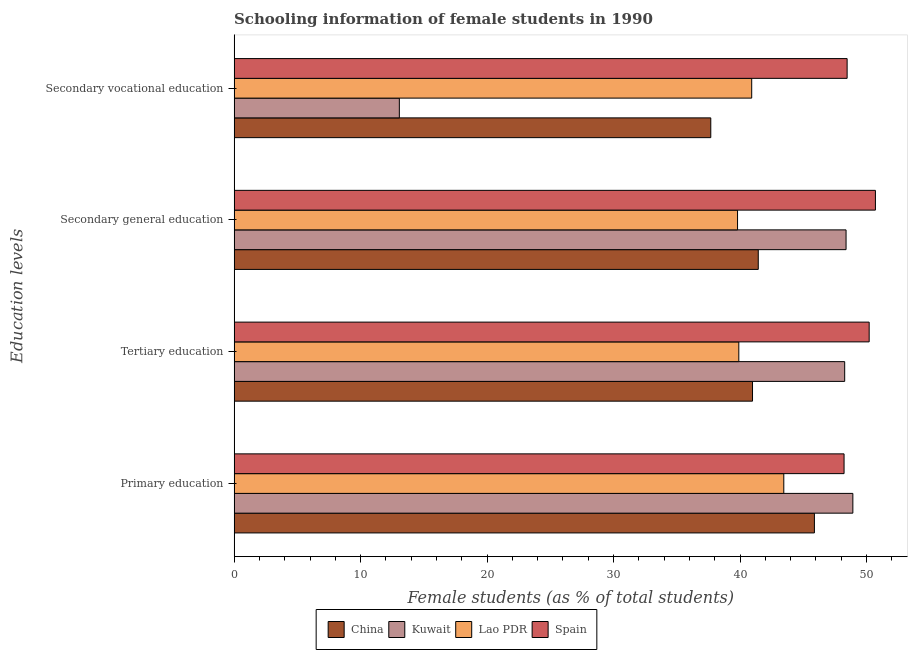How many different coloured bars are there?
Provide a succinct answer. 4. How many groups of bars are there?
Ensure brevity in your answer.  4. What is the label of the 1st group of bars from the top?
Provide a succinct answer. Secondary vocational education. What is the percentage of female students in secondary vocational education in Kuwait?
Make the answer very short. 13.06. Across all countries, what is the maximum percentage of female students in primary education?
Make the answer very short. 48.92. Across all countries, what is the minimum percentage of female students in secondary education?
Provide a short and direct response. 39.8. In which country was the percentage of female students in primary education minimum?
Make the answer very short. Lao PDR. What is the total percentage of female students in tertiary education in the graph?
Offer a very short reply. 179.38. What is the difference between the percentage of female students in primary education in China and that in Kuwait?
Provide a short and direct response. -3.04. What is the difference between the percentage of female students in secondary vocational education in China and the percentage of female students in tertiary education in Lao PDR?
Your answer should be very brief. -2.22. What is the average percentage of female students in secondary vocational education per country?
Offer a very short reply. 35.04. What is the difference between the percentage of female students in primary education and percentage of female students in secondary vocational education in Kuwait?
Provide a short and direct response. 35.86. In how many countries, is the percentage of female students in secondary education greater than 30 %?
Your answer should be very brief. 4. What is the ratio of the percentage of female students in secondary vocational education in Lao PDR to that in Spain?
Make the answer very short. 0.84. Is the percentage of female students in tertiary education in China less than that in Lao PDR?
Offer a terse response. No. What is the difference between the highest and the second highest percentage of female students in tertiary education?
Your response must be concise. 1.94. What is the difference between the highest and the lowest percentage of female students in primary education?
Offer a terse response. 5.46. Is it the case that in every country, the sum of the percentage of female students in secondary education and percentage of female students in tertiary education is greater than the sum of percentage of female students in secondary vocational education and percentage of female students in primary education?
Give a very brief answer. No. What does the 3rd bar from the top in Tertiary education represents?
Ensure brevity in your answer.  Kuwait. What does the 3rd bar from the bottom in Tertiary education represents?
Give a very brief answer. Lao PDR. Is it the case that in every country, the sum of the percentage of female students in primary education and percentage of female students in tertiary education is greater than the percentage of female students in secondary education?
Your response must be concise. Yes. How many bars are there?
Your response must be concise. 16. Are all the bars in the graph horizontal?
Your answer should be very brief. Yes. How many countries are there in the graph?
Make the answer very short. 4. Does the graph contain any zero values?
Give a very brief answer. No. How many legend labels are there?
Provide a short and direct response. 4. How are the legend labels stacked?
Make the answer very short. Horizontal. What is the title of the graph?
Ensure brevity in your answer.  Schooling information of female students in 1990. What is the label or title of the X-axis?
Give a very brief answer. Female students (as % of total students). What is the label or title of the Y-axis?
Ensure brevity in your answer.  Education levels. What is the Female students (as % of total students) of China in Primary education?
Give a very brief answer. 45.88. What is the Female students (as % of total students) of Kuwait in Primary education?
Provide a short and direct response. 48.92. What is the Female students (as % of total students) in Lao PDR in Primary education?
Provide a succinct answer. 43.46. What is the Female students (as % of total students) in Spain in Primary education?
Offer a terse response. 48.23. What is the Female students (as % of total students) in China in Tertiary education?
Your answer should be very brief. 40.99. What is the Female students (as % of total students) of Kuwait in Tertiary education?
Offer a terse response. 48.28. What is the Female students (as % of total students) in Lao PDR in Tertiary education?
Provide a succinct answer. 39.9. What is the Female students (as % of total students) in Spain in Tertiary education?
Your answer should be compact. 50.21. What is the Female students (as % of total students) in China in Secondary general education?
Offer a terse response. 41.44. What is the Female students (as % of total students) of Kuwait in Secondary general education?
Offer a very short reply. 48.38. What is the Female students (as % of total students) in Lao PDR in Secondary general education?
Give a very brief answer. 39.8. What is the Female students (as % of total students) in Spain in Secondary general education?
Provide a short and direct response. 50.71. What is the Female students (as % of total students) in China in Secondary vocational education?
Provide a succinct answer. 37.69. What is the Female students (as % of total students) of Kuwait in Secondary vocational education?
Make the answer very short. 13.06. What is the Female students (as % of total students) in Lao PDR in Secondary vocational education?
Give a very brief answer. 40.92. What is the Female students (as % of total students) in Spain in Secondary vocational education?
Your answer should be compact. 48.47. Across all Education levels, what is the maximum Female students (as % of total students) of China?
Ensure brevity in your answer.  45.88. Across all Education levels, what is the maximum Female students (as % of total students) in Kuwait?
Your answer should be very brief. 48.92. Across all Education levels, what is the maximum Female students (as % of total students) in Lao PDR?
Ensure brevity in your answer.  43.46. Across all Education levels, what is the maximum Female students (as % of total students) of Spain?
Provide a short and direct response. 50.71. Across all Education levels, what is the minimum Female students (as % of total students) in China?
Make the answer very short. 37.69. Across all Education levels, what is the minimum Female students (as % of total students) of Kuwait?
Make the answer very short. 13.06. Across all Education levels, what is the minimum Female students (as % of total students) in Lao PDR?
Make the answer very short. 39.8. Across all Education levels, what is the minimum Female students (as % of total students) in Spain?
Offer a very short reply. 48.23. What is the total Female students (as % of total students) of China in the graph?
Your answer should be compact. 166. What is the total Female students (as % of total students) in Kuwait in the graph?
Provide a short and direct response. 158.65. What is the total Female students (as % of total students) of Lao PDR in the graph?
Your answer should be very brief. 164.09. What is the total Female students (as % of total students) in Spain in the graph?
Offer a terse response. 197.61. What is the difference between the Female students (as % of total students) of China in Primary education and that in Tertiary education?
Offer a very short reply. 4.89. What is the difference between the Female students (as % of total students) in Kuwait in Primary education and that in Tertiary education?
Provide a short and direct response. 0.65. What is the difference between the Female students (as % of total students) in Lao PDR in Primary education and that in Tertiary education?
Your response must be concise. 3.56. What is the difference between the Female students (as % of total students) in Spain in Primary education and that in Tertiary education?
Offer a terse response. -1.98. What is the difference between the Female students (as % of total students) of China in Primary education and that in Secondary general education?
Your answer should be compact. 4.44. What is the difference between the Female students (as % of total students) in Kuwait in Primary education and that in Secondary general education?
Your response must be concise. 0.54. What is the difference between the Female students (as % of total students) in Lao PDR in Primary education and that in Secondary general education?
Offer a terse response. 3.66. What is the difference between the Female students (as % of total students) of Spain in Primary education and that in Secondary general education?
Offer a terse response. -2.48. What is the difference between the Female students (as % of total students) of China in Primary education and that in Secondary vocational education?
Provide a short and direct response. 8.19. What is the difference between the Female students (as % of total students) of Kuwait in Primary education and that in Secondary vocational education?
Ensure brevity in your answer.  35.86. What is the difference between the Female students (as % of total students) of Lao PDR in Primary education and that in Secondary vocational education?
Your response must be concise. 2.54. What is the difference between the Female students (as % of total students) in Spain in Primary education and that in Secondary vocational education?
Offer a terse response. -0.24. What is the difference between the Female students (as % of total students) in China in Tertiary education and that in Secondary general education?
Offer a terse response. -0.45. What is the difference between the Female students (as % of total students) of Kuwait in Tertiary education and that in Secondary general education?
Make the answer very short. -0.11. What is the difference between the Female students (as % of total students) in Lao PDR in Tertiary education and that in Secondary general education?
Ensure brevity in your answer.  0.1. What is the difference between the Female students (as % of total students) of Spain in Tertiary education and that in Secondary general education?
Give a very brief answer. -0.49. What is the difference between the Female students (as % of total students) in China in Tertiary education and that in Secondary vocational education?
Give a very brief answer. 3.3. What is the difference between the Female students (as % of total students) in Kuwait in Tertiary education and that in Secondary vocational education?
Offer a very short reply. 35.21. What is the difference between the Female students (as % of total students) of Lao PDR in Tertiary education and that in Secondary vocational education?
Your response must be concise. -1.02. What is the difference between the Female students (as % of total students) in Spain in Tertiary education and that in Secondary vocational education?
Provide a succinct answer. 1.74. What is the difference between the Female students (as % of total students) of China in Secondary general education and that in Secondary vocational education?
Ensure brevity in your answer.  3.75. What is the difference between the Female students (as % of total students) in Kuwait in Secondary general education and that in Secondary vocational education?
Your answer should be very brief. 35.32. What is the difference between the Female students (as % of total students) in Lao PDR in Secondary general education and that in Secondary vocational education?
Your response must be concise. -1.12. What is the difference between the Female students (as % of total students) in Spain in Secondary general education and that in Secondary vocational education?
Your answer should be very brief. 2.24. What is the difference between the Female students (as % of total students) in China in Primary education and the Female students (as % of total students) in Kuwait in Tertiary education?
Offer a very short reply. -2.39. What is the difference between the Female students (as % of total students) of China in Primary education and the Female students (as % of total students) of Lao PDR in Tertiary education?
Provide a succinct answer. 5.98. What is the difference between the Female students (as % of total students) in China in Primary education and the Female students (as % of total students) in Spain in Tertiary education?
Your response must be concise. -4.33. What is the difference between the Female students (as % of total students) of Kuwait in Primary education and the Female students (as % of total students) of Lao PDR in Tertiary education?
Offer a terse response. 9.02. What is the difference between the Female students (as % of total students) of Kuwait in Primary education and the Female students (as % of total students) of Spain in Tertiary education?
Offer a terse response. -1.29. What is the difference between the Female students (as % of total students) of Lao PDR in Primary education and the Female students (as % of total students) of Spain in Tertiary education?
Your answer should be very brief. -6.75. What is the difference between the Female students (as % of total students) of China in Primary education and the Female students (as % of total students) of Kuwait in Secondary general education?
Make the answer very short. -2.5. What is the difference between the Female students (as % of total students) in China in Primary education and the Female students (as % of total students) in Lao PDR in Secondary general education?
Make the answer very short. 6.08. What is the difference between the Female students (as % of total students) of China in Primary education and the Female students (as % of total students) of Spain in Secondary general education?
Ensure brevity in your answer.  -4.82. What is the difference between the Female students (as % of total students) in Kuwait in Primary education and the Female students (as % of total students) in Lao PDR in Secondary general education?
Offer a very short reply. 9.12. What is the difference between the Female students (as % of total students) in Kuwait in Primary education and the Female students (as % of total students) in Spain in Secondary general education?
Offer a very short reply. -1.78. What is the difference between the Female students (as % of total students) of Lao PDR in Primary education and the Female students (as % of total students) of Spain in Secondary general education?
Your answer should be compact. -7.25. What is the difference between the Female students (as % of total students) of China in Primary education and the Female students (as % of total students) of Kuwait in Secondary vocational education?
Make the answer very short. 32.82. What is the difference between the Female students (as % of total students) of China in Primary education and the Female students (as % of total students) of Lao PDR in Secondary vocational education?
Keep it short and to the point. 4.96. What is the difference between the Female students (as % of total students) in China in Primary education and the Female students (as % of total students) in Spain in Secondary vocational education?
Ensure brevity in your answer.  -2.59. What is the difference between the Female students (as % of total students) in Kuwait in Primary education and the Female students (as % of total students) in Lao PDR in Secondary vocational education?
Your response must be concise. 8. What is the difference between the Female students (as % of total students) in Kuwait in Primary education and the Female students (as % of total students) in Spain in Secondary vocational education?
Make the answer very short. 0.45. What is the difference between the Female students (as % of total students) in Lao PDR in Primary education and the Female students (as % of total students) in Spain in Secondary vocational education?
Provide a short and direct response. -5.01. What is the difference between the Female students (as % of total students) of China in Tertiary education and the Female students (as % of total students) of Kuwait in Secondary general education?
Keep it short and to the point. -7.4. What is the difference between the Female students (as % of total students) in China in Tertiary education and the Female students (as % of total students) in Lao PDR in Secondary general education?
Your answer should be very brief. 1.18. What is the difference between the Female students (as % of total students) in China in Tertiary education and the Female students (as % of total students) in Spain in Secondary general education?
Your answer should be very brief. -9.72. What is the difference between the Female students (as % of total students) in Kuwait in Tertiary education and the Female students (as % of total students) in Lao PDR in Secondary general education?
Offer a terse response. 8.47. What is the difference between the Female students (as % of total students) of Kuwait in Tertiary education and the Female students (as % of total students) of Spain in Secondary general education?
Offer a very short reply. -2.43. What is the difference between the Female students (as % of total students) in Lao PDR in Tertiary education and the Female students (as % of total students) in Spain in Secondary general education?
Your answer should be compact. -10.8. What is the difference between the Female students (as % of total students) in China in Tertiary education and the Female students (as % of total students) in Kuwait in Secondary vocational education?
Give a very brief answer. 27.92. What is the difference between the Female students (as % of total students) in China in Tertiary education and the Female students (as % of total students) in Lao PDR in Secondary vocational education?
Provide a succinct answer. 0.07. What is the difference between the Female students (as % of total students) in China in Tertiary education and the Female students (as % of total students) in Spain in Secondary vocational education?
Offer a very short reply. -7.48. What is the difference between the Female students (as % of total students) in Kuwait in Tertiary education and the Female students (as % of total students) in Lao PDR in Secondary vocational education?
Give a very brief answer. 7.35. What is the difference between the Female students (as % of total students) of Kuwait in Tertiary education and the Female students (as % of total students) of Spain in Secondary vocational education?
Ensure brevity in your answer.  -0.19. What is the difference between the Female students (as % of total students) of Lao PDR in Tertiary education and the Female students (as % of total students) of Spain in Secondary vocational education?
Ensure brevity in your answer.  -8.56. What is the difference between the Female students (as % of total students) in China in Secondary general education and the Female students (as % of total students) in Kuwait in Secondary vocational education?
Give a very brief answer. 28.38. What is the difference between the Female students (as % of total students) in China in Secondary general education and the Female students (as % of total students) in Lao PDR in Secondary vocational education?
Provide a short and direct response. 0.52. What is the difference between the Female students (as % of total students) of China in Secondary general education and the Female students (as % of total students) of Spain in Secondary vocational education?
Offer a terse response. -7.03. What is the difference between the Female students (as % of total students) in Kuwait in Secondary general education and the Female students (as % of total students) in Lao PDR in Secondary vocational education?
Keep it short and to the point. 7.46. What is the difference between the Female students (as % of total students) of Kuwait in Secondary general education and the Female students (as % of total students) of Spain in Secondary vocational education?
Keep it short and to the point. -0.08. What is the difference between the Female students (as % of total students) in Lao PDR in Secondary general education and the Female students (as % of total students) in Spain in Secondary vocational education?
Keep it short and to the point. -8.66. What is the average Female students (as % of total students) in China per Education levels?
Ensure brevity in your answer.  41.5. What is the average Female students (as % of total students) of Kuwait per Education levels?
Provide a succinct answer. 39.66. What is the average Female students (as % of total students) in Lao PDR per Education levels?
Keep it short and to the point. 41.02. What is the average Female students (as % of total students) of Spain per Education levels?
Provide a short and direct response. 49.4. What is the difference between the Female students (as % of total students) in China and Female students (as % of total students) in Kuwait in Primary education?
Provide a succinct answer. -3.04. What is the difference between the Female students (as % of total students) in China and Female students (as % of total students) in Lao PDR in Primary education?
Keep it short and to the point. 2.42. What is the difference between the Female students (as % of total students) of China and Female students (as % of total students) of Spain in Primary education?
Give a very brief answer. -2.35. What is the difference between the Female students (as % of total students) of Kuwait and Female students (as % of total students) of Lao PDR in Primary education?
Your response must be concise. 5.46. What is the difference between the Female students (as % of total students) of Kuwait and Female students (as % of total students) of Spain in Primary education?
Offer a terse response. 0.7. What is the difference between the Female students (as % of total students) of Lao PDR and Female students (as % of total students) of Spain in Primary education?
Offer a very short reply. -4.77. What is the difference between the Female students (as % of total students) in China and Female students (as % of total students) in Kuwait in Tertiary education?
Make the answer very short. -7.29. What is the difference between the Female students (as % of total students) in China and Female students (as % of total students) in Lao PDR in Tertiary education?
Offer a terse response. 1.08. What is the difference between the Female students (as % of total students) of China and Female students (as % of total students) of Spain in Tertiary education?
Keep it short and to the point. -9.22. What is the difference between the Female students (as % of total students) in Kuwait and Female students (as % of total students) in Lao PDR in Tertiary education?
Offer a terse response. 8.37. What is the difference between the Female students (as % of total students) in Kuwait and Female students (as % of total students) in Spain in Tertiary education?
Provide a short and direct response. -1.94. What is the difference between the Female students (as % of total students) in Lao PDR and Female students (as % of total students) in Spain in Tertiary education?
Give a very brief answer. -10.31. What is the difference between the Female students (as % of total students) in China and Female students (as % of total students) in Kuwait in Secondary general education?
Keep it short and to the point. -6.94. What is the difference between the Female students (as % of total students) of China and Female students (as % of total students) of Lao PDR in Secondary general education?
Your answer should be very brief. 1.64. What is the difference between the Female students (as % of total students) of China and Female students (as % of total students) of Spain in Secondary general education?
Your answer should be very brief. -9.26. What is the difference between the Female students (as % of total students) in Kuwait and Female students (as % of total students) in Lao PDR in Secondary general education?
Your response must be concise. 8.58. What is the difference between the Female students (as % of total students) of Kuwait and Female students (as % of total students) of Spain in Secondary general education?
Make the answer very short. -2.32. What is the difference between the Female students (as % of total students) in Lao PDR and Female students (as % of total students) in Spain in Secondary general education?
Provide a succinct answer. -10.9. What is the difference between the Female students (as % of total students) in China and Female students (as % of total students) in Kuwait in Secondary vocational education?
Your answer should be compact. 24.62. What is the difference between the Female students (as % of total students) of China and Female students (as % of total students) of Lao PDR in Secondary vocational education?
Your answer should be compact. -3.24. What is the difference between the Female students (as % of total students) of China and Female students (as % of total students) of Spain in Secondary vocational education?
Provide a short and direct response. -10.78. What is the difference between the Female students (as % of total students) in Kuwait and Female students (as % of total students) in Lao PDR in Secondary vocational education?
Your answer should be very brief. -27.86. What is the difference between the Female students (as % of total students) of Kuwait and Female students (as % of total students) of Spain in Secondary vocational education?
Provide a short and direct response. -35.4. What is the difference between the Female students (as % of total students) in Lao PDR and Female students (as % of total students) in Spain in Secondary vocational education?
Keep it short and to the point. -7.55. What is the ratio of the Female students (as % of total students) of China in Primary education to that in Tertiary education?
Keep it short and to the point. 1.12. What is the ratio of the Female students (as % of total students) of Kuwait in Primary education to that in Tertiary education?
Provide a succinct answer. 1.01. What is the ratio of the Female students (as % of total students) of Lao PDR in Primary education to that in Tertiary education?
Make the answer very short. 1.09. What is the ratio of the Female students (as % of total students) in Spain in Primary education to that in Tertiary education?
Provide a succinct answer. 0.96. What is the ratio of the Female students (as % of total students) of China in Primary education to that in Secondary general education?
Provide a short and direct response. 1.11. What is the ratio of the Female students (as % of total students) of Kuwait in Primary education to that in Secondary general education?
Your answer should be very brief. 1.01. What is the ratio of the Female students (as % of total students) of Lao PDR in Primary education to that in Secondary general education?
Provide a succinct answer. 1.09. What is the ratio of the Female students (as % of total students) in Spain in Primary education to that in Secondary general education?
Your answer should be very brief. 0.95. What is the ratio of the Female students (as % of total students) in China in Primary education to that in Secondary vocational education?
Your answer should be compact. 1.22. What is the ratio of the Female students (as % of total students) of Kuwait in Primary education to that in Secondary vocational education?
Provide a short and direct response. 3.74. What is the ratio of the Female students (as % of total students) in Lao PDR in Primary education to that in Secondary vocational education?
Your answer should be compact. 1.06. What is the ratio of the Female students (as % of total students) in China in Tertiary education to that in Secondary general education?
Provide a succinct answer. 0.99. What is the ratio of the Female students (as % of total students) of Spain in Tertiary education to that in Secondary general education?
Ensure brevity in your answer.  0.99. What is the ratio of the Female students (as % of total students) in China in Tertiary education to that in Secondary vocational education?
Your response must be concise. 1.09. What is the ratio of the Female students (as % of total students) in Kuwait in Tertiary education to that in Secondary vocational education?
Keep it short and to the point. 3.7. What is the ratio of the Female students (as % of total students) in Lao PDR in Tertiary education to that in Secondary vocational education?
Make the answer very short. 0.98. What is the ratio of the Female students (as % of total students) of Spain in Tertiary education to that in Secondary vocational education?
Your answer should be very brief. 1.04. What is the ratio of the Female students (as % of total students) of China in Secondary general education to that in Secondary vocational education?
Your answer should be compact. 1.1. What is the ratio of the Female students (as % of total students) of Kuwait in Secondary general education to that in Secondary vocational education?
Your answer should be very brief. 3.7. What is the ratio of the Female students (as % of total students) of Lao PDR in Secondary general education to that in Secondary vocational education?
Give a very brief answer. 0.97. What is the ratio of the Female students (as % of total students) in Spain in Secondary general education to that in Secondary vocational education?
Keep it short and to the point. 1.05. What is the difference between the highest and the second highest Female students (as % of total students) of China?
Provide a succinct answer. 4.44. What is the difference between the highest and the second highest Female students (as % of total students) in Kuwait?
Your response must be concise. 0.54. What is the difference between the highest and the second highest Female students (as % of total students) in Lao PDR?
Your answer should be very brief. 2.54. What is the difference between the highest and the second highest Female students (as % of total students) of Spain?
Keep it short and to the point. 0.49. What is the difference between the highest and the lowest Female students (as % of total students) in China?
Give a very brief answer. 8.19. What is the difference between the highest and the lowest Female students (as % of total students) of Kuwait?
Provide a succinct answer. 35.86. What is the difference between the highest and the lowest Female students (as % of total students) of Lao PDR?
Your response must be concise. 3.66. What is the difference between the highest and the lowest Female students (as % of total students) of Spain?
Make the answer very short. 2.48. 